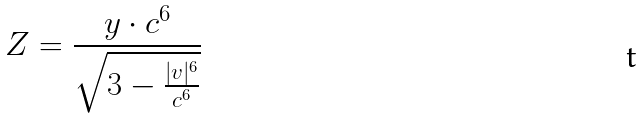<formula> <loc_0><loc_0><loc_500><loc_500>Z = \frac { y \cdot c ^ { 6 } } { \sqrt { 3 - \frac { | v | ^ { 6 } } { c ^ { 6 } } } }</formula> 